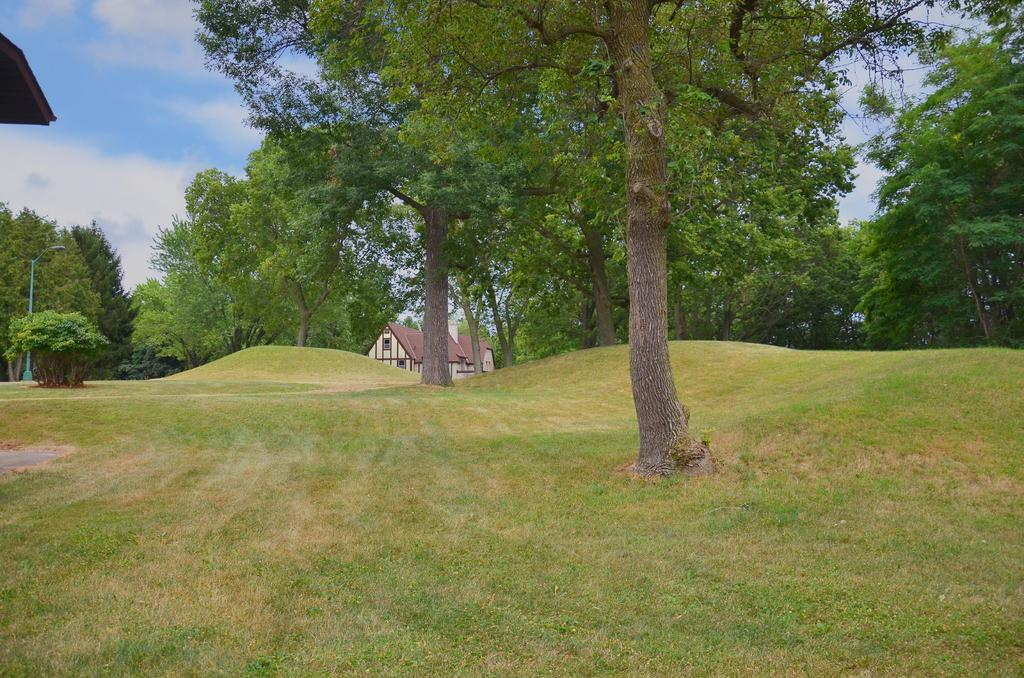What type of ground surface is visible in the image? The ground in the image is covered with grass. What natural elements can be seen in the image? There are many trees in the image. What type of structure is visible in the background of the image? There is a building visible in the background of the image. Can you tell me how many laborers are fighting over the lead in the image? There is no reference to laborers, fighting, or lead in the image; it primarily features grass, trees, and a building in the background. 